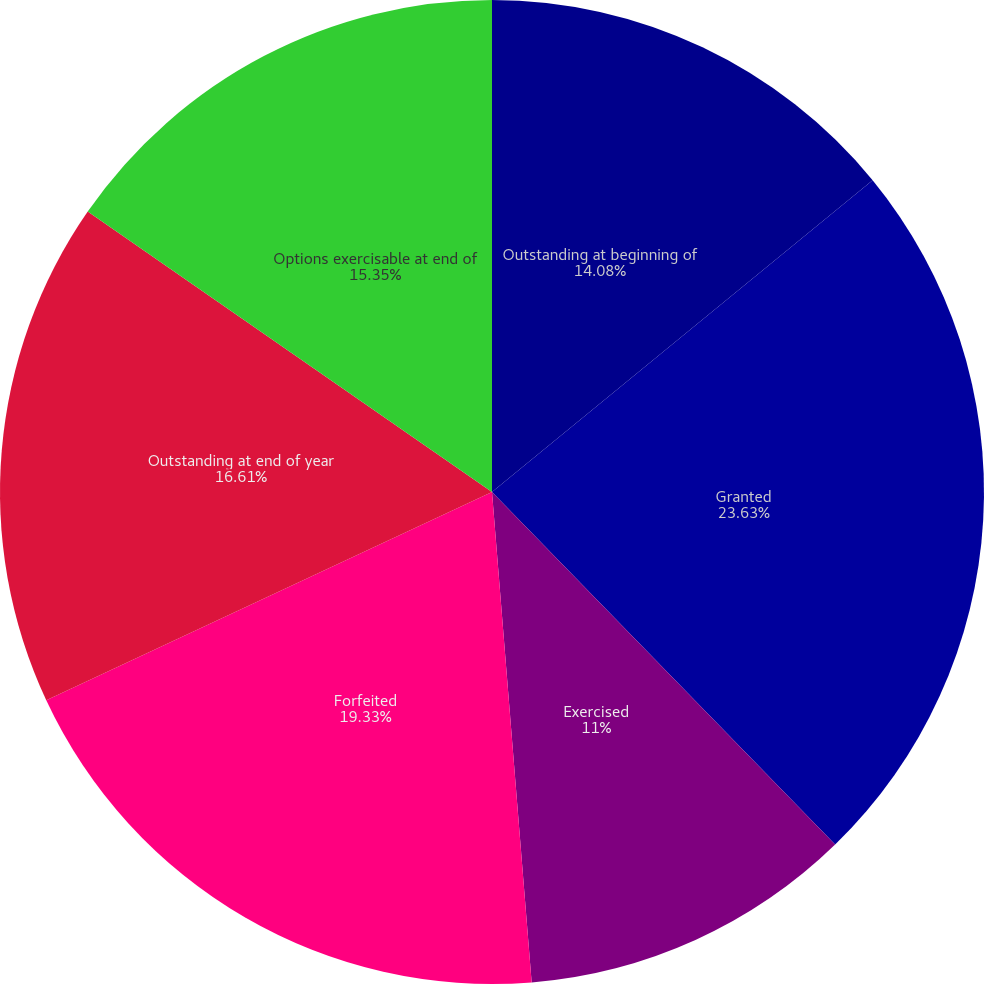Convert chart. <chart><loc_0><loc_0><loc_500><loc_500><pie_chart><fcel>Outstanding at beginning of<fcel>Granted<fcel>Exercised<fcel>Forfeited<fcel>Outstanding at end of year<fcel>Options exercisable at end of<nl><fcel>14.08%<fcel>23.64%<fcel>11.0%<fcel>19.33%<fcel>16.61%<fcel>15.35%<nl></chart> 